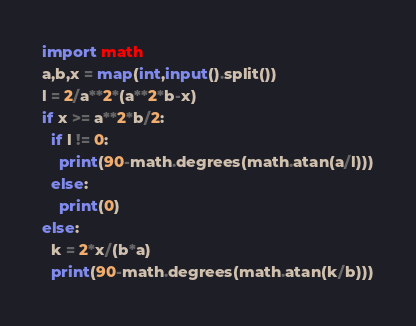<code> <loc_0><loc_0><loc_500><loc_500><_Python_>import math
a,b,x = map(int,input().split())
l = 2/a**2*(a**2*b-x)
if x >= a**2*b/2:
  if l != 0:
    print(90-math.degrees(math.atan(a/l)))
  else:
    print(0)
else:
  k = 2*x/(b*a)
  print(90-math.degrees(math.atan(k/b)))
</code> 